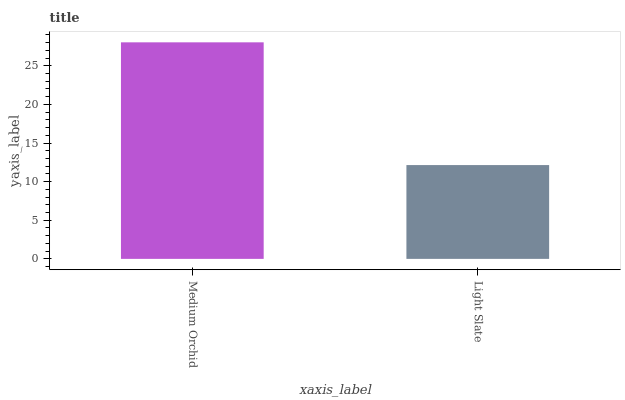Is Light Slate the minimum?
Answer yes or no. Yes. Is Medium Orchid the maximum?
Answer yes or no. Yes. Is Light Slate the maximum?
Answer yes or no. No. Is Medium Orchid greater than Light Slate?
Answer yes or no. Yes. Is Light Slate less than Medium Orchid?
Answer yes or no. Yes. Is Light Slate greater than Medium Orchid?
Answer yes or no. No. Is Medium Orchid less than Light Slate?
Answer yes or no. No. Is Medium Orchid the high median?
Answer yes or no. Yes. Is Light Slate the low median?
Answer yes or no. Yes. Is Light Slate the high median?
Answer yes or no. No. Is Medium Orchid the low median?
Answer yes or no. No. 